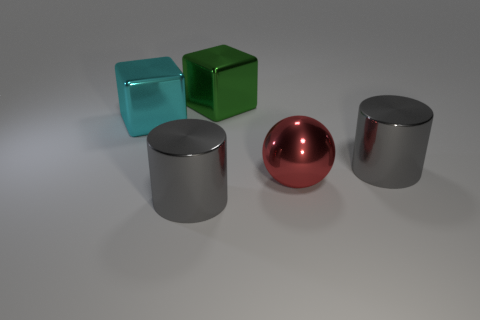Add 2 blue cubes. How many objects exist? 7 Subtract all cubes. How many objects are left? 3 Add 4 green balls. How many green balls exist? 4 Subtract 0 green cylinders. How many objects are left? 5 Subtract all large green metallic objects. Subtract all yellow shiny spheres. How many objects are left? 4 Add 4 big objects. How many big objects are left? 9 